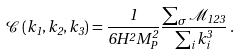<formula> <loc_0><loc_0><loc_500><loc_500>\mathcal { C } \left ( k _ { 1 } , k _ { 2 } , k _ { 3 } \right ) = \frac { 1 } { 6 H ^ { 2 } M _ { P } ^ { 2 } } \frac { \sum _ { \sigma } \mathcal { M } _ { 1 2 3 } } { \sum _ { i } k _ { i } ^ { 3 } } \, .</formula> 